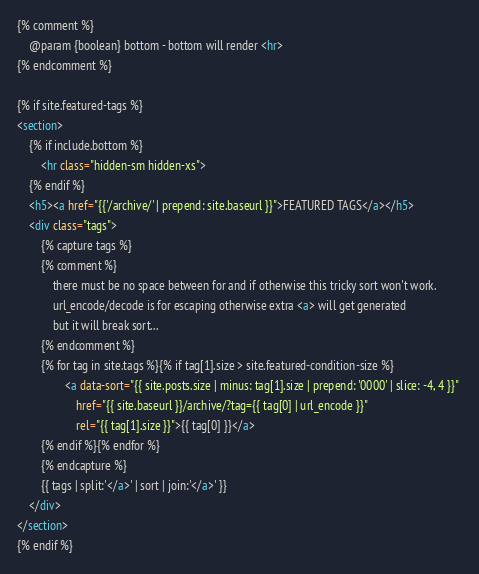<code> <loc_0><loc_0><loc_500><loc_500><_HTML_>{% comment %}
    @param {boolean} bottom - bottom will render <hr> 
{% endcomment %}

{% if site.featured-tags %}
<section>
    {% if include.bottom %}
        <hr class="hidden-sm hidden-xs">
    {% endif %}
    <h5><a href="{{'/archive/' | prepend: site.baseurl }}">FEATURED TAGS</a></h5>
    <div class="tags">
        {% capture tags %}
        {% comment %}
            there must be no space between for and if otherwise this tricky sort won't work.
            url_encode/decode is for escaping otherwise extra <a> will get generated 
            but it will break sort...
        {% endcomment %}
        {% for tag in site.tags %}{% if tag[1].size > site.featured-condition-size %}
                <a data-sort="{{ site.posts.size | minus: tag[1].size | prepend: '0000' | slice: -4, 4 }}" 
                    href="{{ site.baseurl }}/archive/?tag={{ tag[0] | url_encode }}"
                    rel="{{ tag[1].size }}">{{ tag[0] }}</a>
        {% endif %}{% endfor %}
        {% endcapture %}
        {{ tags | split:'</a>' | sort | join:'</a>' }}
    </div>
</section>
{% endif %}</code> 